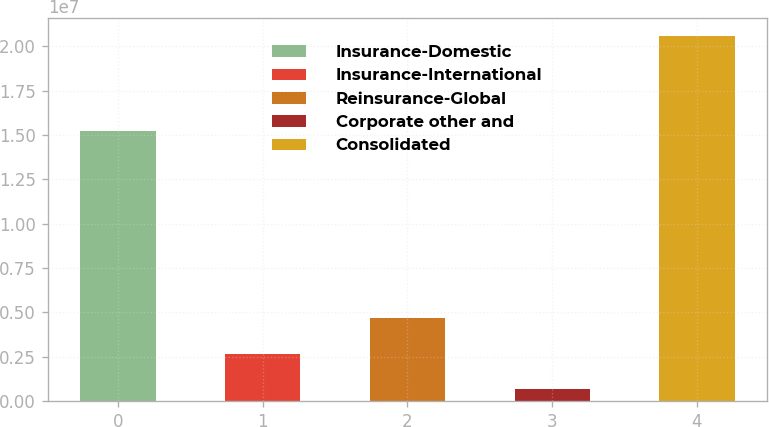Convert chart to OTSL. <chart><loc_0><loc_0><loc_500><loc_500><bar_chart><fcel>Insurance-Domestic<fcel>Insurance-International<fcel>Reinsurance-Global<fcel>Corporate other and<fcel>Consolidated<nl><fcel>1.52478e+07<fcel>2.67122e+06<fcel>4.65795e+06<fcel>684486<fcel>2.05518e+07<nl></chart> 